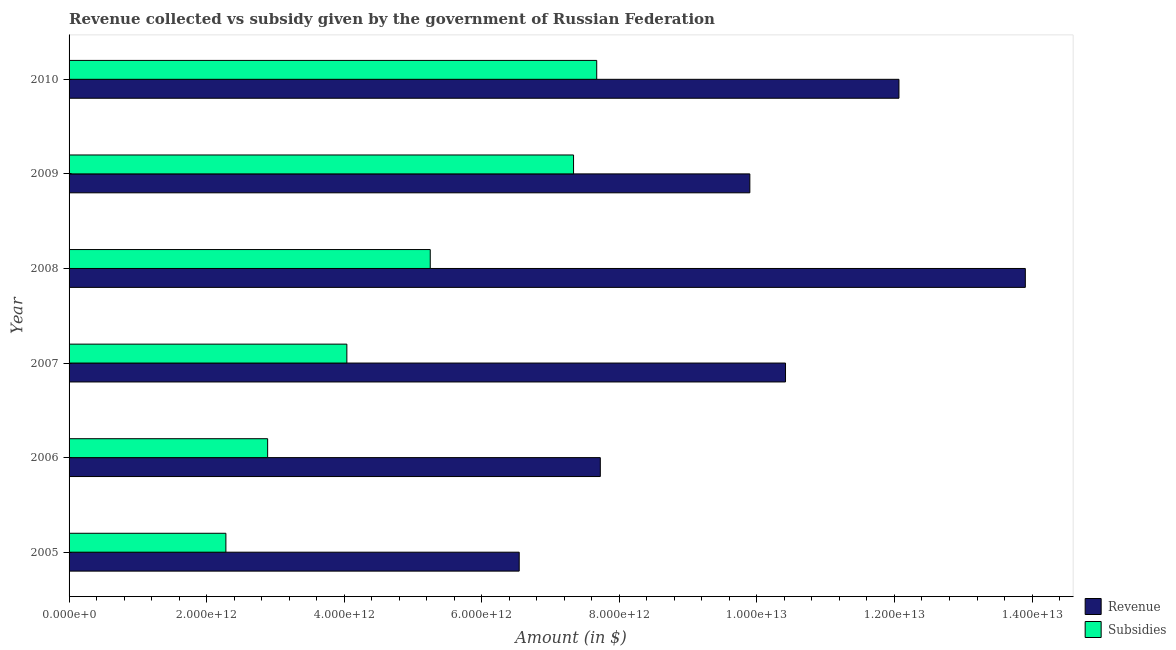Are the number of bars per tick equal to the number of legend labels?
Offer a terse response. Yes. Are the number of bars on each tick of the Y-axis equal?
Your answer should be compact. Yes. What is the label of the 5th group of bars from the top?
Ensure brevity in your answer.  2006. In how many cases, is the number of bars for a given year not equal to the number of legend labels?
Your answer should be compact. 0. What is the amount of subsidies given in 2010?
Offer a very short reply. 7.67e+12. Across all years, what is the maximum amount of revenue collected?
Ensure brevity in your answer.  1.39e+13. Across all years, what is the minimum amount of subsidies given?
Keep it short and to the point. 2.28e+12. What is the total amount of revenue collected in the graph?
Offer a very short reply. 6.05e+13. What is the difference between the amount of subsidies given in 2007 and that in 2008?
Your answer should be compact. -1.21e+12. What is the difference between the amount of revenue collected in 2010 and the amount of subsidies given in 2009?
Provide a succinct answer. 4.73e+12. What is the average amount of revenue collected per year?
Make the answer very short. 1.01e+13. In the year 2009, what is the difference between the amount of revenue collected and amount of subsidies given?
Keep it short and to the point. 2.56e+12. What is the ratio of the amount of subsidies given in 2007 to that in 2010?
Make the answer very short. 0.53. What is the difference between the highest and the second highest amount of revenue collected?
Your answer should be compact. 1.84e+12. What is the difference between the highest and the lowest amount of subsidies given?
Your answer should be compact. 5.39e+12. In how many years, is the amount of revenue collected greater than the average amount of revenue collected taken over all years?
Offer a terse response. 3. What does the 1st bar from the top in 2009 represents?
Your answer should be very brief. Subsidies. What does the 2nd bar from the bottom in 2008 represents?
Provide a succinct answer. Subsidies. How many bars are there?
Give a very brief answer. 12. How many years are there in the graph?
Your answer should be compact. 6. What is the difference between two consecutive major ticks on the X-axis?
Offer a very short reply. 2.00e+12. Are the values on the major ticks of X-axis written in scientific E-notation?
Provide a succinct answer. Yes. Does the graph contain grids?
Provide a short and direct response. No. Where does the legend appear in the graph?
Offer a very short reply. Bottom right. What is the title of the graph?
Ensure brevity in your answer.  Revenue collected vs subsidy given by the government of Russian Federation. Does "Net National savings" appear as one of the legend labels in the graph?
Your answer should be compact. No. What is the label or title of the X-axis?
Provide a succinct answer. Amount (in $). What is the Amount (in $) of Revenue in 2005?
Offer a terse response. 6.54e+12. What is the Amount (in $) in Subsidies in 2005?
Provide a short and direct response. 2.28e+12. What is the Amount (in $) of Revenue in 2006?
Provide a succinct answer. 7.72e+12. What is the Amount (in $) in Subsidies in 2006?
Give a very brief answer. 2.89e+12. What is the Amount (in $) in Revenue in 2007?
Keep it short and to the point. 1.04e+13. What is the Amount (in $) in Subsidies in 2007?
Offer a terse response. 4.04e+12. What is the Amount (in $) in Revenue in 2008?
Your response must be concise. 1.39e+13. What is the Amount (in $) in Subsidies in 2008?
Ensure brevity in your answer.  5.25e+12. What is the Amount (in $) in Revenue in 2009?
Offer a very short reply. 9.90e+12. What is the Amount (in $) of Subsidies in 2009?
Your answer should be very brief. 7.33e+12. What is the Amount (in $) in Revenue in 2010?
Provide a short and direct response. 1.21e+13. What is the Amount (in $) of Subsidies in 2010?
Keep it short and to the point. 7.67e+12. Across all years, what is the maximum Amount (in $) in Revenue?
Your answer should be very brief. 1.39e+13. Across all years, what is the maximum Amount (in $) in Subsidies?
Keep it short and to the point. 7.67e+12. Across all years, what is the minimum Amount (in $) of Revenue?
Ensure brevity in your answer.  6.54e+12. Across all years, what is the minimum Amount (in $) in Subsidies?
Ensure brevity in your answer.  2.28e+12. What is the total Amount (in $) in Revenue in the graph?
Offer a very short reply. 6.05e+13. What is the total Amount (in $) in Subsidies in the graph?
Make the answer very short. 2.95e+13. What is the difference between the Amount (in $) of Revenue in 2005 and that in 2006?
Ensure brevity in your answer.  -1.18e+12. What is the difference between the Amount (in $) in Subsidies in 2005 and that in 2006?
Keep it short and to the point. -6.07e+11. What is the difference between the Amount (in $) of Revenue in 2005 and that in 2007?
Offer a terse response. -3.87e+12. What is the difference between the Amount (in $) in Subsidies in 2005 and that in 2007?
Your answer should be very brief. -1.76e+12. What is the difference between the Amount (in $) in Revenue in 2005 and that in 2008?
Your response must be concise. -7.36e+12. What is the difference between the Amount (in $) of Subsidies in 2005 and that in 2008?
Your response must be concise. -2.97e+12. What is the difference between the Amount (in $) in Revenue in 2005 and that in 2009?
Keep it short and to the point. -3.35e+12. What is the difference between the Amount (in $) in Subsidies in 2005 and that in 2009?
Your response must be concise. -5.05e+12. What is the difference between the Amount (in $) in Revenue in 2005 and that in 2010?
Provide a succinct answer. -5.52e+12. What is the difference between the Amount (in $) in Subsidies in 2005 and that in 2010?
Your answer should be compact. -5.39e+12. What is the difference between the Amount (in $) of Revenue in 2006 and that in 2007?
Offer a very short reply. -2.69e+12. What is the difference between the Amount (in $) of Subsidies in 2006 and that in 2007?
Offer a terse response. -1.15e+12. What is the difference between the Amount (in $) of Revenue in 2006 and that in 2008?
Your response must be concise. -6.18e+12. What is the difference between the Amount (in $) in Subsidies in 2006 and that in 2008?
Offer a terse response. -2.36e+12. What is the difference between the Amount (in $) in Revenue in 2006 and that in 2009?
Your answer should be very brief. -2.17e+12. What is the difference between the Amount (in $) in Subsidies in 2006 and that in 2009?
Make the answer very short. -4.45e+12. What is the difference between the Amount (in $) of Revenue in 2006 and that in 2010?
Provide a short and direct response. -4.34e+12. What is the difference between the Amount (in $) of Subsidies in 2006 and that in 2010?
Offer a terse response. -4.78e+12. What is the difference between the Amount (in $) in Revenue in 2007 and that in 2008?
Make the answer very short. -3.49e+12. What is the difference between the Amount (in $) of Subsidies in 2007 and that in 2008?
Your response must be concise. -1.21e+12. What is the difference between the Amount (in $) in Revenue in 2007 and that in 2009?
Provide a short and direct response. 5.18e+11. What is the difference between the Amount (in $) in Subsidies in 2007 and that in 2009?
Offer a terse response. -3.30e+12. What is the difference between the Amount (in $) of Revenue in 2007 and that in 2010?
Make the answer very short. -1.65e+12. What is the difference between the Amount (in $) of Subsidies in 2007 and that in 2010?
Keep it short and to the point. -3.63e+12. What is the difference between the Amount (in $) in Revenue in 2008 and that in 2009?
Offer a very short reply. 4.01e+12. What is the difference between the Amount (in $) in Subsidies in 2008 and that in 2009?
Your response must be concise. -2.08e+12. What is the difference between the Amount (in $) of Revenue in 2008 and that in 2010?
Provide a succinct answer. 1.84e+12. What is the difference between the Amount (in $) of Subsidies in 2008 and that in 2010?
Keep it short and to the point. -2.42e+12. What is the difference between the Amount (in $) in Revenue in 2009 and that in 2010?
Your response must be concise. -2.17e+12. What is the difference between the Amount (in $) of Subsidies in 2009 and that in 2010?
Offer a very short reply. -3.37e+11. What is the difference between the Amount (in $) of Revenue in 2005 and the Amount (in $) of Subsidies in 2006?
Make the answer very short. 3.66e+12. What is the difference between the Amount (in $) in Revenue in 2005 and the Amount (in $) in Subsidies in 2007?
Your answer should be very brief. 2.51e+12. What is the difference between the Amount (in $) of Revenue in 2005 and the Amount (in $) of Subsidies in 2008?
Keep it short and to the point. 1.29e+12. What is the difference between the Amount (in $) of Revenue in 2005 and the Amount (in $) of Subsidies in 2009?
Your response must be concise. -7.90e+11. What is the difference between the Amount (in $) of Revenue in 2005 and the Amount (in $) of Subsidies in 2010?
Your response must be concise. -1.13e+12. What is the difference between the Amount (in $) of Revenue in 2006 and the Amount (in $) of Subsidies in 2007?
Your answer should be compact. 3.68e+12. What is the difference between the Amount (in $) of Revenue in 2006 and the Amount (in $) of Subsidies in 2008?
Keep it short and to the point. 2.47e+12. What is the difference between the Amount (in $) of Revenue in 2006 and the Amount (in $) of Subsidies in 2009?
Your answer should be very brief. 3.89e+11. What is the difference between the Amount (in $) of Revenue in 2006 and the Amount (in $) of Subsidies in 2010?
Your answer should be very brief. 5.23e+1. What is the difference between the Amount (in $) of Revenue in 2007 and the Amount (in $) of Subsidies in 2008?
Offer a terse response. 5.16e+12. What is the difference between the Amount (in $) of Revenue in 2007 and the Amount (in $) of Subsidies in 2009?
Keep it short and to the point. 3.08e+12. What is the difference between the Amount (in $) in Revenue in 2007 and the Amount (in $) in Subsidies in 2010?
Give a very brief answer. 2.74e+12. What is the difference between the Amount (in $) in Revenue in 2008 and the Amount (in $) in Subsidies in 2009?
Ensure brevity in your answer.  6.57e+12. What is the difference between the Amount (in $) of Revenue in 2008 and the Amount (in $) of Subsidies in 2010?
Ensure brevity in your answer.  6.23e+12. What is the difference between the Amount (in $) of Revenue in 2009 and the Amount (in $) of Subsidies in 2010?
Give a very brief answer. 2.23e+12. What is the average Amount (in $) in Revenue per year?
Provide a short and direct response. 1.01e+13. What is the average Amount (in $) in Subsidies per year?
Give a very brief answer. 4.91e+12. In the year 2005, what is the difference between the Amount (in $) of Revenue and Amount (in $) of Subsidies?
Your answer should be compact. 4.26e+12. In the year 2006, what is the difference between the Amount (in $) of Revenue and Amount (in $) of Subsidies?
Give a very brief answer. 4.84e+12. In the year 2007, what is the difference between the Amount (in $) of Revenue and Amount (in $) of Subsidies?
Provide a succinct answer. 6.38e+12. In the year 2008, what is the difference between the Amount (in $) of Revenue and Amount (in $) of Subsidies?
Offer a very short reply. 8.65e+12. In the year 2009, what is the difference between the Amount (in $) in Revenue and Amount (in $) in Subsidies?
Provide a succinct answer. 2.56e+12. In the year 2010, what is the difference between the Amount (in $) in Revenue and Amount (in $) in Subsidies?
Your response must be concise. 4.39e+12. What is the ratio of the Amount (in $) of Revenue in 2005 to that in 2006?
Provide a succinct answer. 0.85. What is the ratio of the Amount (in $) of Subsidies in 2005 to that in 2006?
Provide a short and direct response. 0.79. What is the ratio of the Amount (in $) in Revenue in 2005 to that in 2007?
Your answer should be compact. 0.63. What is the ratio of the Amount (in $) in Subsidies in 2005 to that in 2007?
Make the answer very short. 0.56. What is the ratio of the Amount (in $) of Revenue in 2005 to that in 2008?
Offer a very short reply. 0.47. What is the ratio of the Amount (in $) in Subsidies in 2005 to that in 2008?
Give a very brief answer. 0.43. What is the ratio of the Amount (in $) in Revenue in 2005 to that in 2009?
Provide a short and direct response. 0.66. What is the ratio of the Amount (in $) in Subsidies in 2005 to that in 2009?
Offer a terse response. 0.31. What is the ratio of the Amount (in $) of Revenue in 2005 to that in 2010?
Your answer should be very brief. 0.54. What is the ratio of the Amount (in $) in Subsidies in 2005 to that in 2010?
Make the answer very short. 0.3. What is the ratio of the Amount (in $) of Revenue in 2006 to that in 2007?
Offer a very short reply. 0.74. What is the ratio of the Amount (in $) in Subsidies in 2006 to that in 2007?
Your answer should be very brief. 0.71. What is the ratio of the Amount (in $) of Revenue in 2006 to that in 2008?
Make the answer very short. 0.56. What is the ratio of the Amount (in $) in Subsidies in 2006 to that in 2008?
Your answer should be compact. 0.55. What is the ratio of the Amount (in $) in Revenue in 2006 to that in 2009?
Your answer should be very brief. 0.78. What is the ratio of the Amount (in $) in Subsidies in 2006 to that in 2009?
Give a very brief answer. 0.39. What is the ratio of the Amount (in $) of Revenue in 2006 to that in 2010?
Provide a succinct answer. 0.64. What is the ratio of the Amount (in $) of Subsidies in 2006 to that in 2010?
Your answer should be compact. 0.38. What is the ratio of the Amount (in $) in Revenue in 2007 to that in 2008?
Provide a short and direct response. 0.75. What is the ratio of the Amount (in $) of Subsidies in 2007 to that in 2008?
Your response must be concise. 0.77. What is the ratio of the Amount (in $) in Revenue in 2007 to that in 2009?
Your response must be concise. 1.05. What is the ratio of the Amount (in $) in Subsidies in 2007 to that in 2009?
Make the answer very short. 0.55. What is the ratio of the Amount (in $) of Revenue in 2007 to that in 2010?
Ensure brevity in your answer.  0.86. What is the ratio of the Amount (in $) of Subsidies in 2007 to that in 2010?
Your answer should be compact. 0.53. What is the ratio of the Amount (in $) of Revenue in 2008 to that in 2009?
Offer a very short reply. 1.4. What is the ratio of the Amount (in $) in Subsidies in 2008 to that in 2009?
Make the answer very short. 0.72. What is the ratio of the Amount (in $) of Revenue in 2008 to that in 2010?
Keep it short and to the point. 1.15. What is the ratio of the Amount (in $) of Subsidies in 2008 to that in 2010?
Ensure brevity in your answer.  0.68. What is the ratio of the Amount (in $) of Revenue in 2009 to that in 2010?
Give a very brief answer. 0.82. What is the ratio of the Amount (in $) of Subsidies in 2009 to that in 2010?
Ensure brevity in your answer.  0.96. What is the difference between the highest and the second highest Amount (in $) in Revenue?
Your response must be concise. 1.84e+12. What is the difference between the highest and the second highest Amount (in $) in Subsidies?
Your answer should be very brief. 3.37e+11. What is the difference between the highest and the lowest Amount (in $) of Revenue?
Your answer should be very brief. 7.36e+12. What is the difference between the highest and the lowest Amount (in $) in Subsidies?
Offer a very short reply. 5.39e+12. 